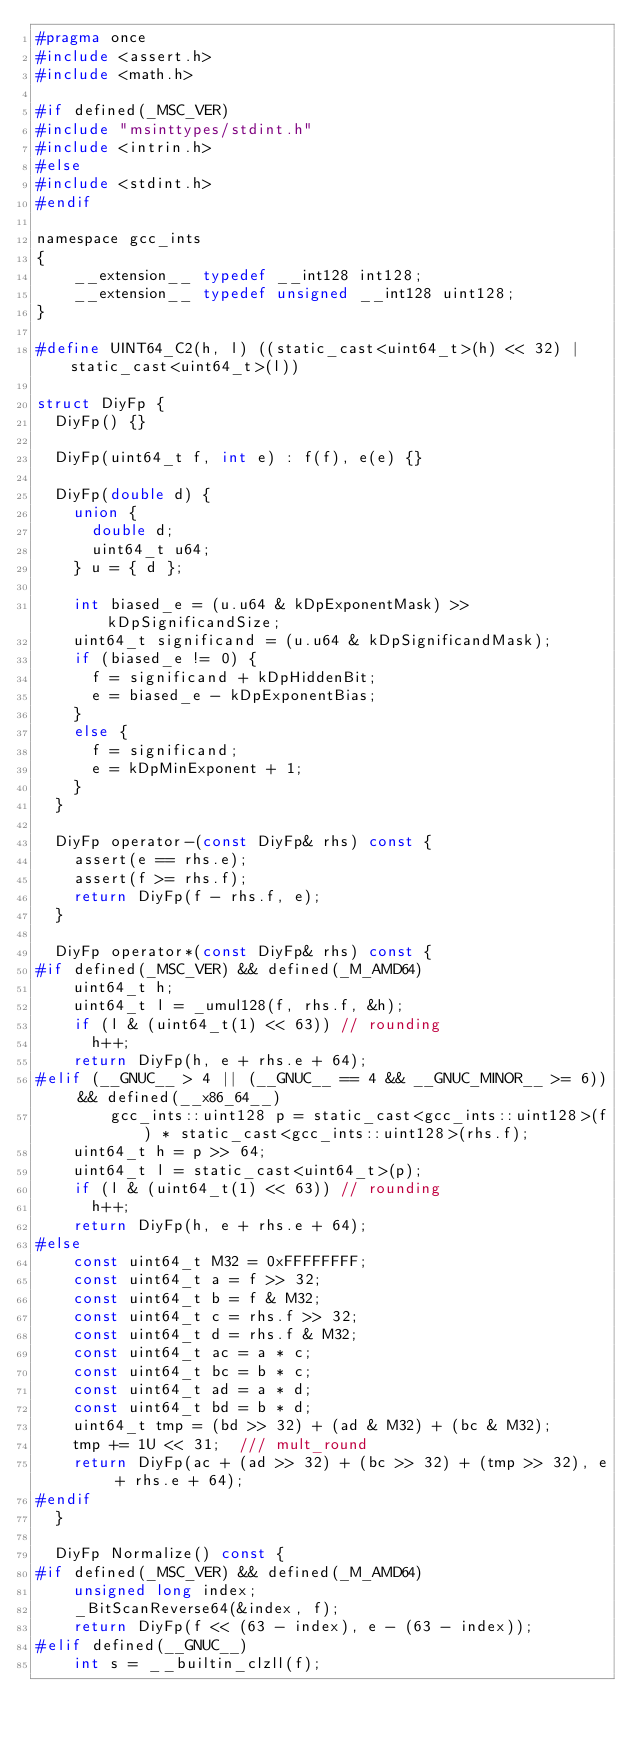Convert code to text. <code><loc_0><loc_0><loc_500><loc_500><_C_>#pragma once
#include <assert.h>
#include <math.h>

#if defined(_MSC_VER)
#include "msinttypes/stdint.h"
#include <intrin.h>
#else
#include <stdint.h>
#endif

namespace gcc_ints
{
    __extension__ typedef __int128 int128;
    __extension__ typedef unsigned __int128 uint128;
}

#define UINT64_C2(h, l) ((static_cast<uint64_t>(h) << 32) | static_cast<uint64_t>(l))

struct DiyFp {
	DiyFp() {}

	DiyFp(uint64_t f, int e) : f(f), e(e) {}

	DiyFp(double d) {
		union {
			double d;
			uint64_t u64;
		} u = { d };

		int biased_e = (u.u64 & kDpExponentMask) >> kDpSignificandSize;
		uint64_t significand = (u.u64 & kDpSignificandMask);
		if (biased_e != 0) {
			f = significand + kDpHiddenBit;
			e = biased_e - kDpExponentBias;
		} 
		else {
			f = significand;
			e = kDpMinExponent + 1;
		}
	}

	DiyFp operator-(const DiyFp& rhs) const {
		assert(e == rhs.e);
		assert(f >= rhs.f);
		return DiyFp(f - rhs.f, e);
	}

	DiyFp operator*(const DiyFp& rhs) const {
#if defined(_MSC_VER) && defined(_M_AMD64)
		uint64_t h;
		uint64_t l = _umul128(f, rhs.f, &h);
		if (l & (uint64_t(1) << 63)) // rounding
			h++;
		return DiyFp(h, e + rhs.e + 64);
#elif (__GNUC__ > 4 || (__GNUC__ == 4 && __GNUC_MINOR__ >= 6)) && defined(__x86_64__)
        gcc_ints::uint128 p = static_cast<gcc_ints::uint128>(f) * static_cast<gcc_ints::uint128>(rhs.f);
		uint64_t h = p >> 64;
		uint64_t l = static_cast<uint64_t>(p);
		if (l & (uint64_t(1) << 63)) // rounding
			h++;
		return DiyFp(h, e + rhs.e + 64);
#else
		const uint64_t M32 = 0xFFFFFFFF;
		const uint64_t a = f >> 32;
		const uint64_t b = f & M32;
		const uint64_t c = rhs.f >> 32;
		const uint64_t d = rhs.f & M32;
		const uint64_t ac = a * c;
		const uint64_t bc = b * c;
		const uint64_t ad = a * d;
		const uint64_t bd = b * d;
		uint64_t tmp = (bd >> 32) + (ad & M32) + (bc & M32);
		tmp += 1U << 31;  /// mult_round
		return DiyFp(ac + (ad >> 32) + (bc >> 32) + (tmp >> 32), e + rhs.e + 64);
#endif
	}

	DiyFp Normalize() const {
#if defined(_MSC_VER) && defined(_M_AMD64)
		unsigned long index;
		_BitScanReverse64(&index, f);
		return DiyFp(f << (63 - index), e - (63 - index));
#elif defined(__GNUC__)
		int s = __builtin_clzll(f);</code> 